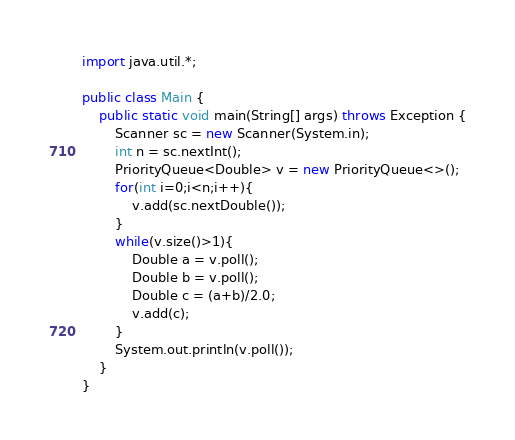Convert code to text. <code><loc_0><loc_0><loc_500><loc_500><_Java_>
import java.util.*;

public class Main {
    public static void main(String[] args) throws Exception {
        Scanner sc = new Scanner(System.in);
        int n = sc.nextInt();
        PriorityQueue<Double> v = new PriorityQueue<>();
        for(int i=0;i<n;i++){
            v.add(sc.nextDouble());
        }
        while(v.size()>1){
            Double a = v.poll();
            Double b = v.poll();
            Double c = (a+b)/2.0;
            v.add(c);
        }
        System.out.println(v.poll());
    }
}</code> 